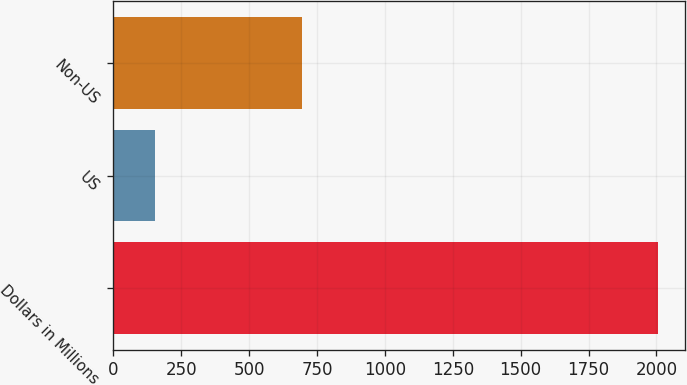<chart> <loc_0><loc_0><loc_500><loc_500><bar_chart><fcel>Dollars in Millions<fcel>US<fcel>Non-US<nl><fcel>2006<fcel>154<fcel>693<nl></chart> 